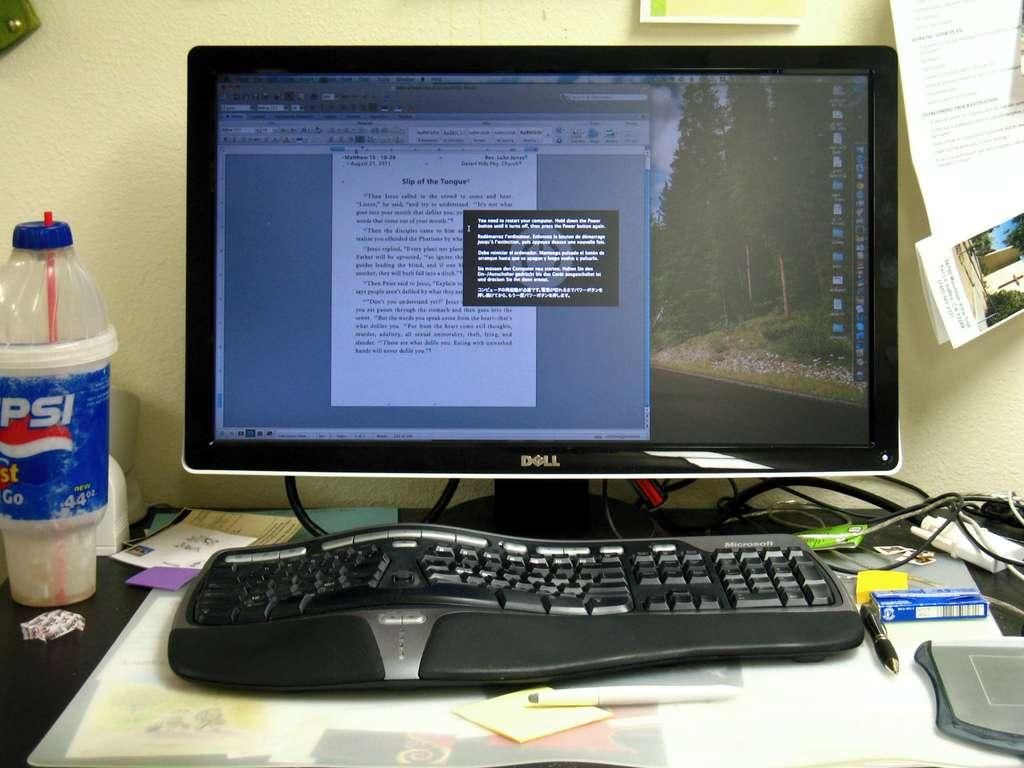<image>
Create a compact narrative representing the image presented. a computer with a document that says slip of the tongue 